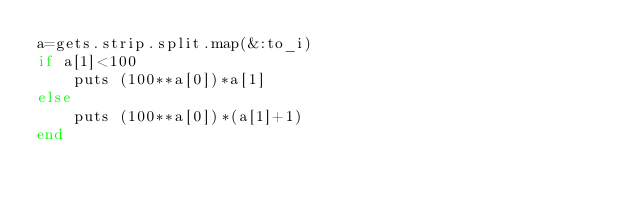<code> <loc_0><loc_0><loc_500><loc_500><_Ruby_>a=gets.strip.split.map(&:to_i)
if a[1]<100
	puts (100**a[0])*a[1]
else
	puts (100**a[0])*(a[1]+1)
end</code> 